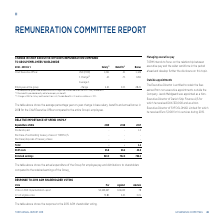According to Torm's financial document, What does the information in the table show? the actual expenditure of the Group for employee pay and distributions to shareholders compared to the retained earnings of the Group. The document states: "The table above shows the actual expenditure of the Group for employee pay and distributions to shareholders compared to the retained earnings of the ..." Also, What is the retained earnings for 2019? According to the financial document, 920.0 (in millions). The relevant text states: "Retained earnings 920.0 752.0 786.0..." Also, For which years is the actual expenditure of the Group for employee pay and distributions to shareholders compared to the retained earnings of the Group in the table? The document contains multiple relevant values: 2019, 2018, 2017. From the document: "Expenditure USDm 2019 2018 2017 Expenditure USDm 2019 2018 2017 Expenditure USDm 2019 2018 2017..." Additionally, In which year were the staff costs the largest? According to the financial document, 2018. The relevant text states: "Expenditure USDm 2019 2018 2017..." Also, can you calculate: What was the change in retained earnings in 2019 from 2018? Based on the calculation: 920.0-752.0, the result is 168 (in millions). This is based on the information: "Retained earnings 920.0 752.0 786.0 Retained earnings 920.0 752.0 786.0..." The key data points involved are: 752.0, 920.0. Also, can you calculate: What was the percentage change in retained earnings in 2019 from 2018? To answer this question, I need to perform calculations using the financial data. The calculation is: (920.0-752.0)/752.0, which equals 22.34 (percentage). This is based on the information: "Retained earnings 920.0 752.0 786.0 Retained earnings 920.0 752.0 786.0..." The key data points involved are: 752.0, 920.0. 